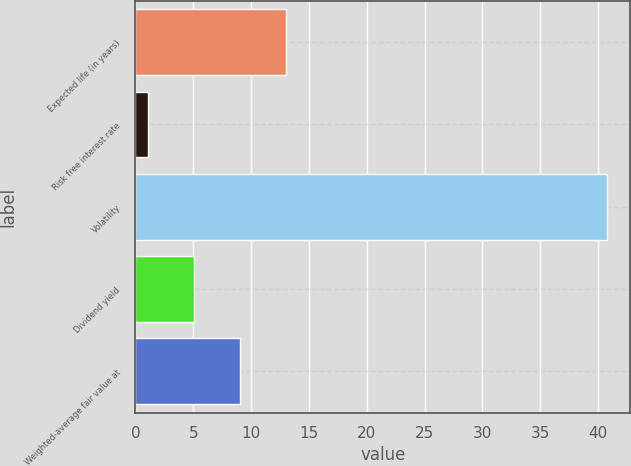Convert chart. <chart><loc_0><loc_0><loc_500><loc_500><bar_chart><fcel>Expected life (in years)<fcel>Risk free interest rate<fcel>Volatility<fcel>Dividend yield<fcel>Weighted-average fair value at<nl><fcel>13<fcel>1.12<fcel>40.76<fcel>5.08<fcel>9.04<nl></chart> 